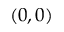Convert formula to latex. <formula><loc_0><loc_0><loc_500><loc_500>( 0 , 0 )</formula> 